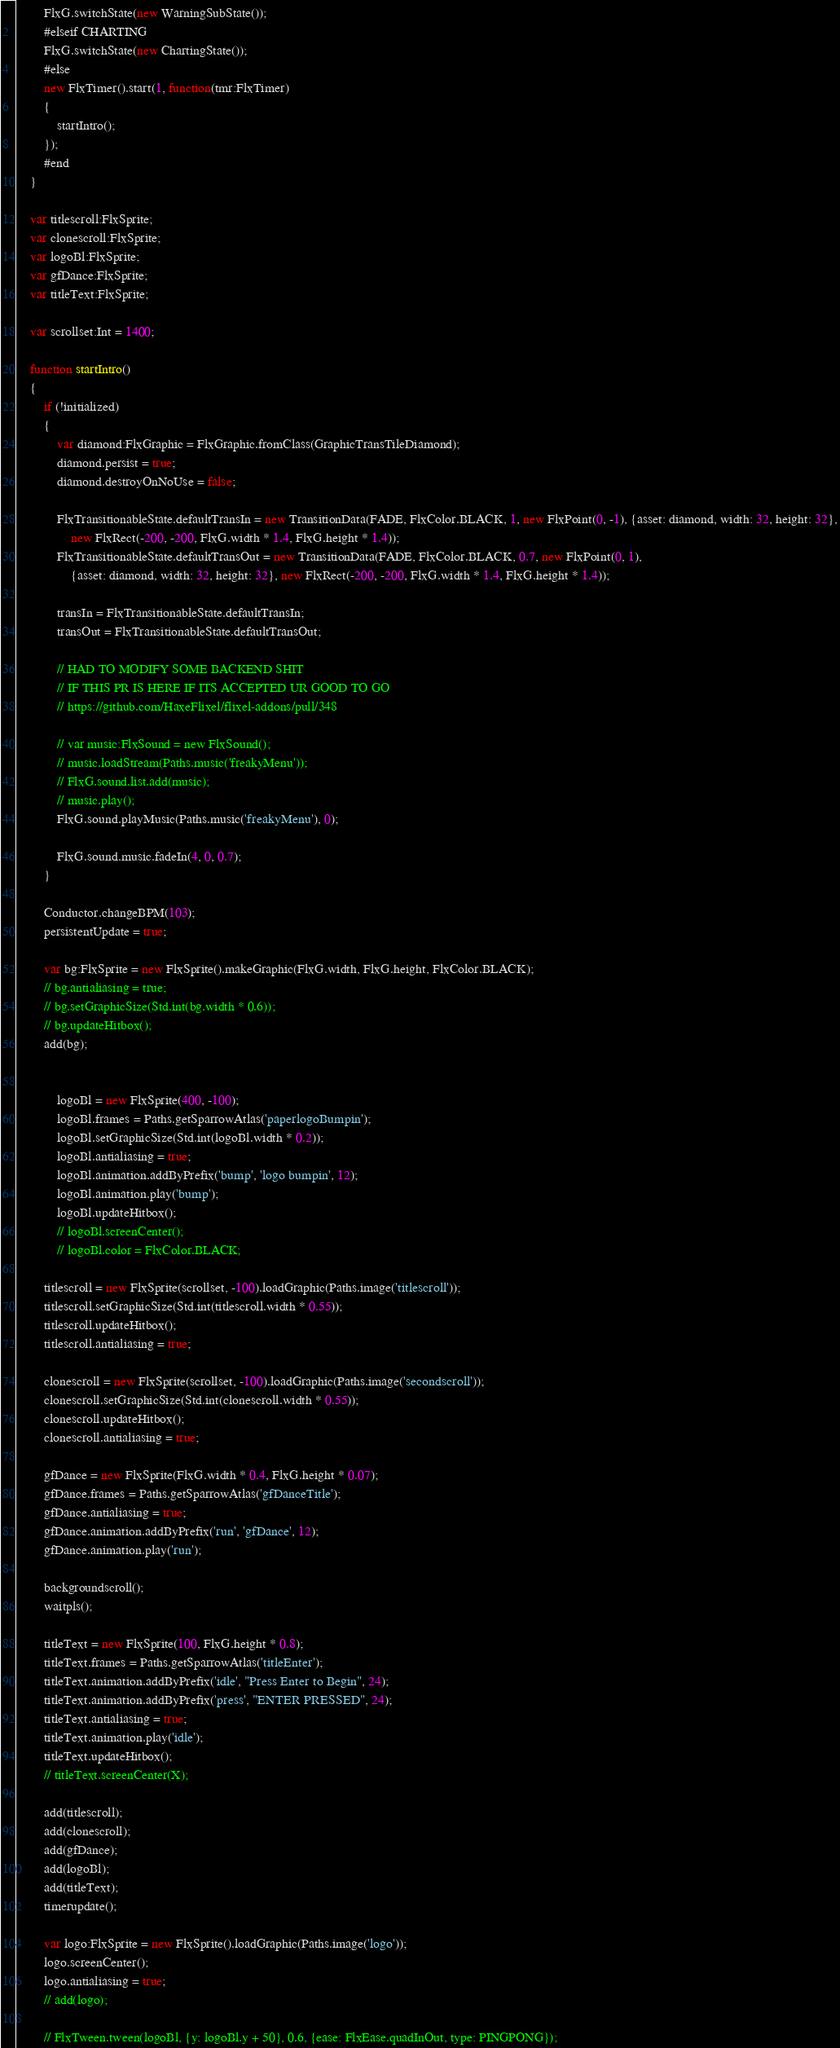Convert code to text. <code><loc_0><loc_0><loc_500><loc_500><_Haxe_>		FlxG.switchState(new WarningSubState());
		#elseif CHARTING
		FlxG.switchState(new ChartingState());
		#else
		new FlxTimer().start(1, function(tmr:FlxTimer)
		{
			startIntro();
		});
		#end
	}

	var titlescroll:FlxSprite;
	var clonescroll:FlxSprite;
	var logoBl:FlxSprite;
	var gfDance:FlxSprite;
	var titleText:FlxSprite;

	var scrollset:Int = 1400;

	function startIntro()
	{
		if (!initialized)
		{
			var diamond:FlxGraphic = FlxGraphic.fromClass(GraphicTransTileDiamond);
			diamond.persist = true;
			diamond.destroyOnNoUse = false;

			FlxTransitionableState.defaultTransIn = new TransitionData(FADE, FlxColor.BLACK, 1, new FlxPoint(0, -1), {asset: diamond, width: 32, height: 32},
				new FlxRect(-200, -200, FlxG.width * 1.4, FlxG.height * 1.4));
			FlxTransitionableState.defaultTransOut = new TransitionData(FADE, FlxColor.BLACK, 0.7, new FlxPoint(0, 1),
				{asset: diamond, width: 32, height: 32}, new FlxRect(-200, -200, FlxG.width * 1.4, FlxG.height * 1.4));

			transIn = FlxTransitionableState.defaultTransIn;
			transOut = FlxTransitionableState.defaultTransOut;

			// HAD TO MODIFY SOME BACKEND SHIT
			// IF THIS PR IS HERE IF ITS ACCEPTED UR GOOD TO GO
			// https://github.com/HaxeFlixel/flixel-addons/pull/348

			// var music:FlxSound = new FlxSound();
			// music.loadStream(Paths.music('freakyMenu'));
			// FlxG.sound.list.add(music);
			// music.play();
			FlxG.sound.playMusic(Paths.music('freakyMenu'), 0);

			FlxG.sound.music.fadeIn(4, 0, 0.7);
		}

		Conductor.changeBPM(103);
		persistentUpdate = true;

		var bg:FlxSprite = new FlxSprite().makeGraphic(FlxG.width, FlxG.height, FlxColor.BLACK);
		// bg.antialiasing = true;
		// bg.setGraphicSize(Std.int(bg.width * 0.6));
		// bg.updateHitbox();
		add(bg);

		
			logoBl = new FlxSprite(400, -100);
			logoBl.frames = Paths.getSparrowAtlas('paperlogoBumpin');
			logoBl.setGraphicSize(Std.int(logoBl.width * 0.2));
			logoBl.antialiasing = true;
			logoBl.animation.addByPrefix('bump', 'logo bumpin', 12);
			logoBl.animation.play('bump');
			logoBl.updateHitbox();
			// logoBl.screenCenter();
			// logoBl.color = FlxColor.BLACK;

		titlescroll = new FlxSprite(scrollset, -100).loadGraphic(Paths.image('titlescroll'));
		titlescroll.setGraphicSize(Std.int(titlescroll.width * 0.55));
		titlescroll.updateHitbox();
		titlescroll.antialiasing = true;

		clonescroll = new FlxSprite(scrollset, -100).loadGraphic(Paths.image('secondscroll'));
		clonescroll.setGraphicSize(Std.int(clonescroll.width * 0.55));
		clonescroll.updateHitbox();
		clonescroll.antialiasing = true;

		gfDance = new FlxSprite(FlxG.width * 0.4, FlxG.height * 0.07);
		gfDance.frames = Paths.getSparrowAtlas('gfDanceTitle');
		gfDance.antialiasing = true;
		gfDance.animation.addByPrefix('run', 'gfDance', 12);
		gfDance.animation.play('run');

		backgroundscroll();
		waitpls();

		titleText = new FlxSprite(100, FlxG.height * 0.8);
		titleText.frames = Paths.getSparrowAtlas('titleEnter');
		titleText.animation.addByPrefix('idle', "Press Enter to Begin", 24);
		titleText.animation.addByPrefix('press', "ENTER PRESSED", 24);
		titleText.antialiasing = true;
		titleText.animation.play('idle');
		titleText.updateHitbox();
		// titleText.screenCenter(X);

		add(titlescroll);
		add(clonescroll);
		add(gfDance);
		add(logoBl);
		add(titleText);
		timerupdate();

		var logo:FlxSprite = new FlxSprite().loadGraphic(Paths.image('logo'));
		logo.screenCenter();
		logo.antialiasing = true;
		// add(logo);

		// FlxTween.tween(logoBl, {y: logoBl.y + 50}, 0.6, {ease: FlxEase.quadInOut, type: PINGPONG});</code> 